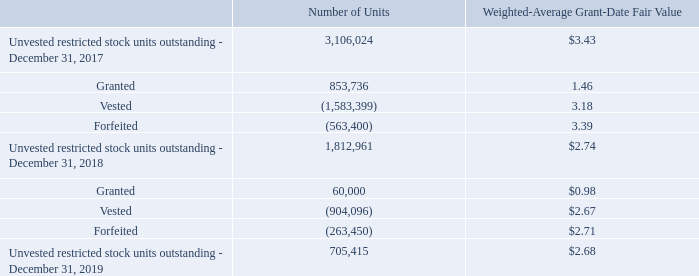Restricted Stock Units
The Company intends to settle all vested restricted stock unit payments held by United States-based participants in shares of the Company’s common stock and classifies these awards as equity awards in its Consolidated Balance Sheets. Awards held by participants who are based outside of the United States will be settled in cash and are classified within accrued and other current liabilities on the Consolidated Balance Sheets as of December 31, 2019 and 2018
The following table summarizes the activity related to the unvested restricted stock units during the years ended December 31, 2019 and 2018:
Unrecognized compensation expense related to unvested restricted stock units was $731 at December 31, 2019, which is expected to be recognized as expense over the weighted-average period of 0.7 years.
During the years ended December 31, 2019 and 2018, the Company issued 642,520 and 782,364 shares, respectively, of common stock to participants of the 2016 Plan based in the United States, after withholding approximately 261,335 and 472,965 shares, respectively, to satisfy tax withholding obligations. The Company made a cash payment of $181 and $1,495 to cover employee withholding taxes upon the settlement of these vested restricted stock units during the years ended December 31, 2019 and 2018, respectively. During the years ended December 31, 2019 and 2018, the Company also paid $0 and $300 to cash-settle 16 and 100,025 vested restricted stock units by agreement with the Chief Operating Officer in relation to certain grants made to him and to pay cash in lieu of fractional shares for vested units held by participants based in the United States.
What are the respective number of units granted and vested in 2017? 853,736, 1,583,399. What are the respective number of units granted and vested in 2018? 60,000, 904,096. What are the respective number of units forfeited in 2017 and 2018? 563,400, 263,450. What is the average number of units granted in 2017 and 2018? (853,736 + 60,000)/2 
Answer: 456868. What is the average number of units vested in 2017 and 2018? (1,583,399 + 904,096)/2 
Answer: 1243747.5. What is the average number of units forfeited in 2017 and 2018? (563,400 + 263,450)/2 
Answer: 413425. 